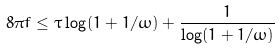<formula> <loc_0><loc_0><loc_500><loc_500>8 \pi f \leq \tau \log ( 1 + 1 / \omega ) + \frac { 1 } { \log ( 1 + 1 / \omega ) }</formula> 